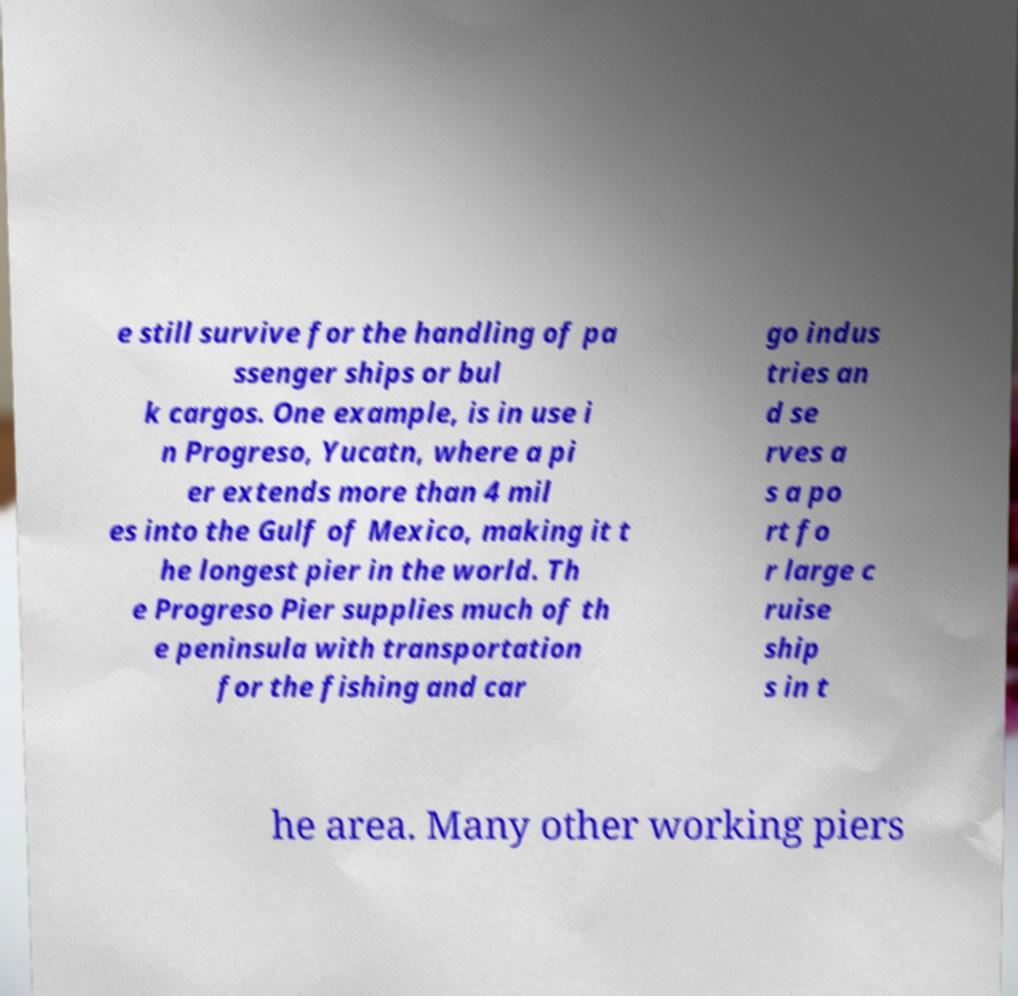Please read and relay the text visible in this image. What does it say? e still survive for the handling of pa ssenger ships or bul k cargos. One example, is in use i n Progreso, Yucatn, where a pi er extends more than 4 mil es into the Gulf of Mexico, making it t he longest pier in the world. Th e Progreso Pier supplies much of th e peninsula with transportation for the fishing and car go indus tries an d se rves a s a po rt fo r large c ruise ship s in t he area. Many other working piers 